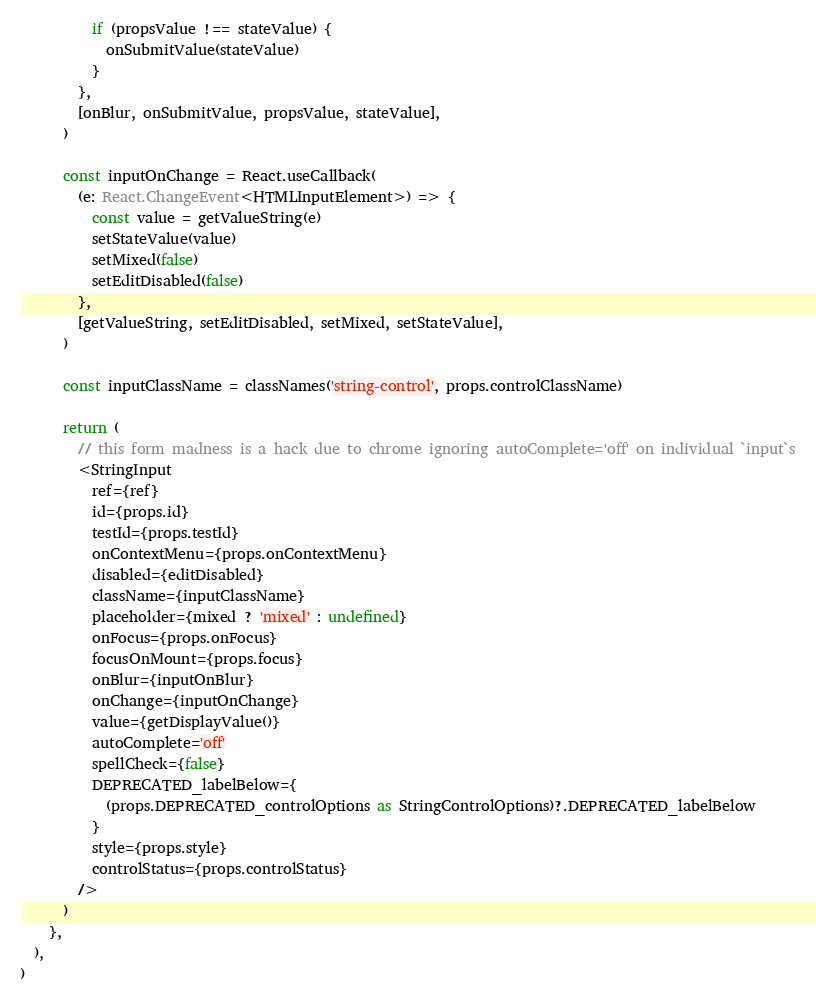Convert code to text. <code><loc_0><loc_0><loc_500><loc_500><_TypeScript_>          if (propsValue !== stateValue) {
            onSubmitValue(stateValue)
          }
        },
        [onBlur, onSubmitValue, propsValue, stateValue],
      )

      const inputOnChange = React.useCallback(
        (e: React.ChangeEvent<HTMLInputElement>) => {
          const value = getValueString(e)
          setStateValue(value)
          setMixed(false)
          setEditDisabled(false)
        },
        [getValueString, setEditDisabled, setMixed, setStateValue],
      )

      const inputClassName = classNames('string-control', props.controlClassName)

      return (
        // this form madness is a hack due to chrome ignoring autoComplete='off' on individual `input`s
        <StringInput
          ref={ref}
          id={props.id}
          testId={props.testId}
          onContextMenu={props.onContextMenu}
          disabled={editDisabled}
          className={inputClassName}
          placeholder={mixed ? 'mixed' : undefined}
          onFocus={props.onFocus}
          focusOnMount={props.focus}
          onBlur={inputOnBlur}
          onChange={inputOnChange}
          value={getDisplayValue()}
          autoComplete='off'
          spellCheck={false}
          DEPRECATED_labelBelow={
            (props.DEPRECATED_controlOptions as StringControlOptions)?.DEPRECATED_labelBelow
          }
          style={props.style}
          controlStatus={props.controlStatus}
        />
      )
    },
  ),
)
</code> 